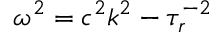<formula> <loc_0><loc_0><loc_500><loc_500>\omega ^ { 2 } = c ^ { 2 } k ^ { 2 } - \tau _ { r } ^ { - 2 }</formula> 